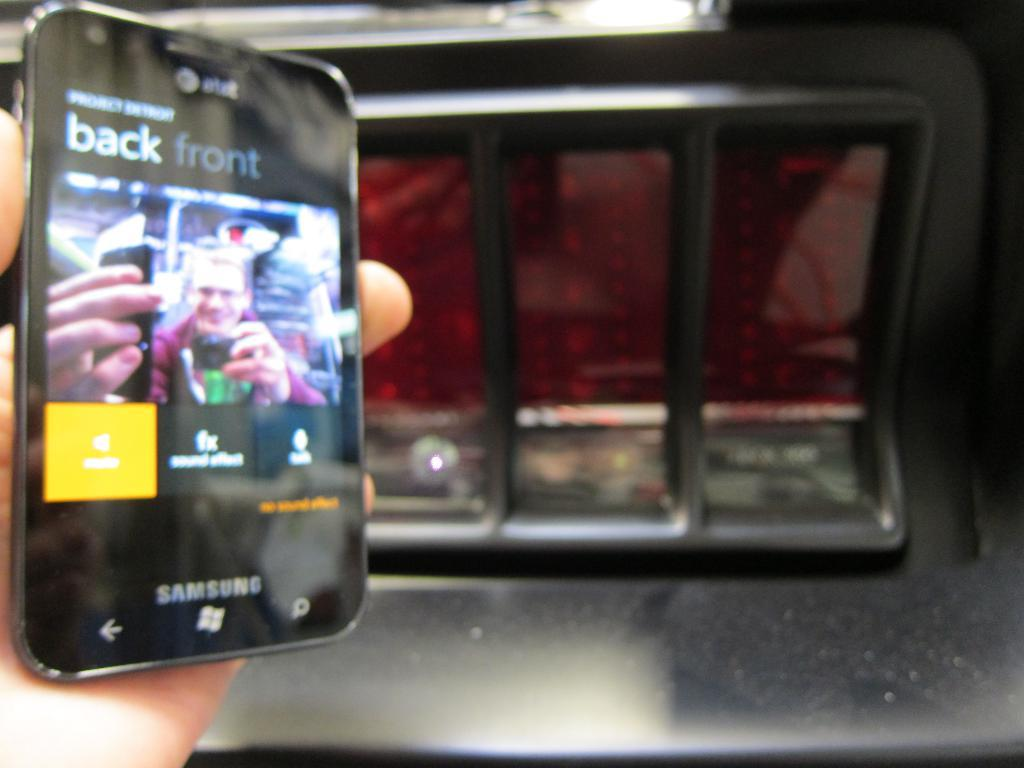<image>
Describe the image concisely. A person is conducting a video chat on a Samsung phone. 